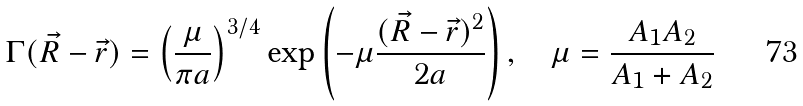<formula> <loc_0><loc_0><loc_500><loc_500>\Gamma ( \vec { R } - \vec { r } ) = \left ( \frac { \mu } { \pi a } \right ) ^ { 3 / 4 } \exp \left ( - \mu \frac { ( \vec { R } - \vec { r } ) ^ { 2 } } { 2 a } \right ) , \quad \mu = \frac { A _ { 1 } A _ { 2 } } { A _ { 1 } + A _ { 2 } }</formula> 